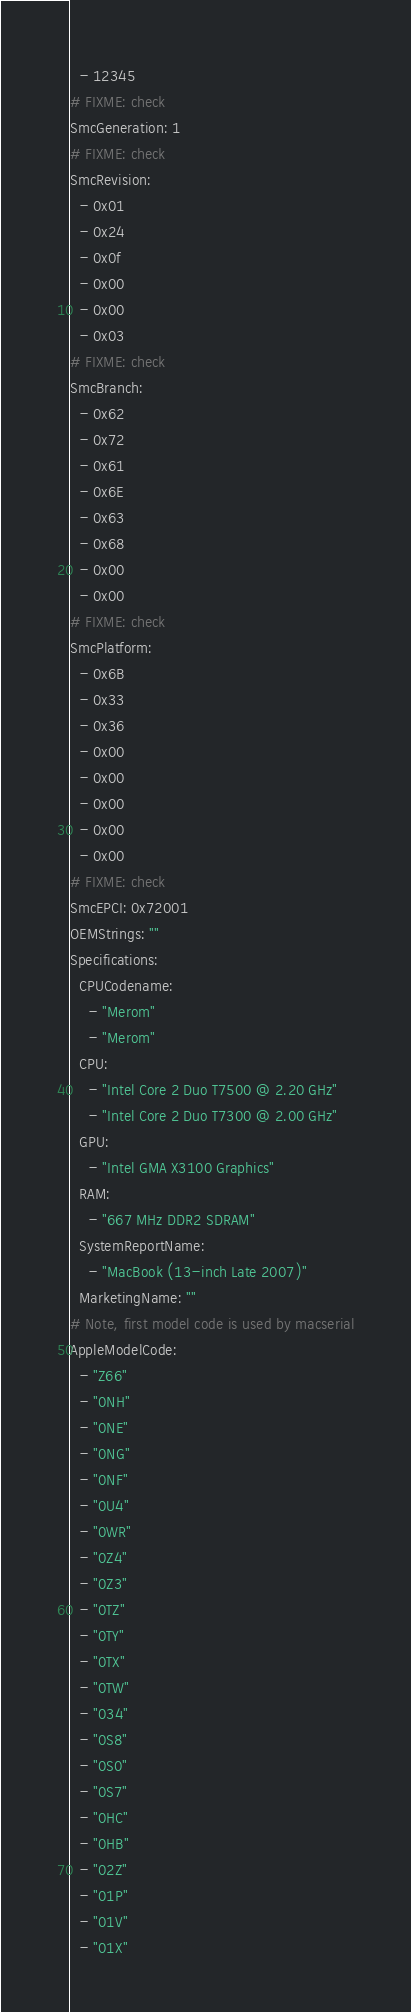Convert code to text. <code><loc_0><loc_0><loc_500><loc_500><_YAML_>  - 12345
# FIXME: check
SmcGeneration: 1
# FIXME: check
SmcRevision:
  - 0x01
  - 0x24
  - 0x0f
  - 0x00
  - 0x00
  - 0x03
# FIXME: check
SmcBranch:
  - 0x62
  - 0x72
  - 0x61
  - 0x6E
  - 0x63
  - 0x68
  - 0x00
  - 0x00
# FIXME: check
SmcPlatform:
  - 0x6B
  - 0x33
  - 0x36
  - 0x00
  - 0x00
  - 0x00
  - 0x00
  - 0x00
# FIXME: check
SmcEPCI: 0x72001
OEMStrings: ""
Specifications:
  CPUCodename:
    - "Merom"
    - "Merom"
  CPU:
    - "Intel Core 2 Duo T7500 @ 2.20 GHz"
    - "Intel Core 2 Duo T7300 @ 2.00 GHz"
  GPU:
    - "Intel GMA X3100 Graphics"
  RAM:
    - "667 MHz DDR2 SDRAM"
  SystemReportName:
    - "MacBook (13-inch Late 2007)"
  MarketingName: ""
# Note, first model code is used by macserial
AppleModelCode:
  - "Z66"
  - "0NH"
  - "0NE"
  - "0NG"
  - "0NF"
  - "0U4"
  - "0WR"
  - "0Z4"
  - "0Z3"
  - "0TZ"
  - "0TY"
  - "0TX"
  - "0TW"
  - "034"
  - "0S8"
  - "0S0"
  - "0S7"
  - "0HC"
  - "0HB"
  - "02Z"
  - "01P"
  - "01V"
  - "01X"</code> 